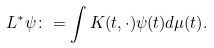<formula> <loc_0><loc_0><loc_500><loc_500>L ^ { \ast } \psi \colon = \int K ( t , \cdot ) \psi ( t ) d \mu ( t ) .</formula> 